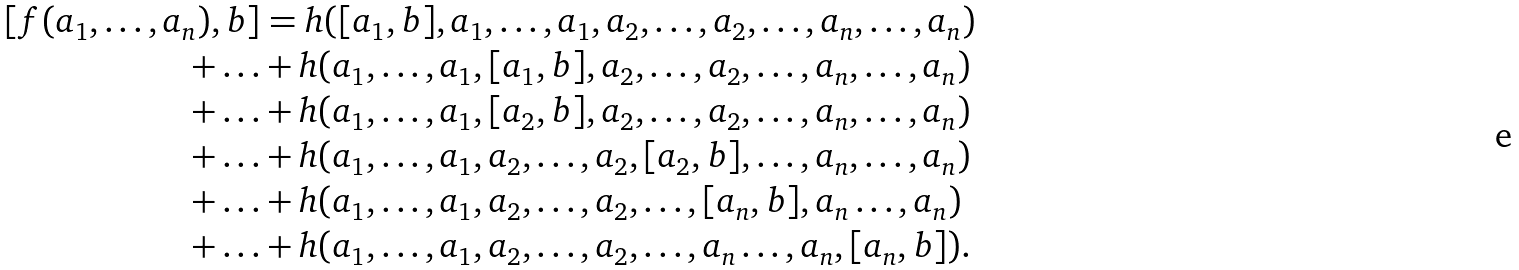<formula> <loc_0><loc_0><loc_500><loc_500>[ f ( a _ { 1 } , \dots , a _ { n } ) , b ] & = h ( [ a _ { 1 } , b ] , a _ { 1 } , \dots , a _ { 1 } , a _ { 2 } , \dots , a _ { 2 } , \dots , a _ { n } , \dots , a _ { n } ) \\ + \dots & + h ( a _ { 1 } , \dots , a _ { 1 } , [ a _ { 1 } , b ] , a _ { 2 } , \dots , a _ { 2 } , \dots , a _ { n } , \dots , a _ { n } ) \\ + \dots & + h ( a _ { 1 } , \dots , a _ { 1 } , [ a _ { 2 } , b ] , a _ { 2 } , \dots , a _ { 2 } , \dots , a _ { n } , \dots , a _ { n } ) \\ + \dots & + h ( a _ { 1 } , \dots , a _ { 1 } , a _ { 2 } , \dots , a _ { 2 } , [ a _ { 2 } , b ] , \dots , a _ { n } , \dots , a _ { n } ) \\ + \dots & + h ( a _ { 1 } , \dots , a _ { 1 } , a _ { 2 } , \dots , a _ { 2 } , \dots , [ a _ { n } , b ] , a _ { n } \dots , a _ { n } ) \\ + \dots & + h ( a _ { 1 } , \dots , a _ { 1 } , a _ { 2 } , \dots , a _ { 2 } , \dots , a _ { n } \dots , a _ { n } , [ a _ { n } , b ] ) .</formula> 